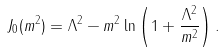Convert formula to latex. <formula><loc_0><loc_0><loc_500><loc_500>J _ { 0 } ( m ^ { 2 } ) = \Lambda ^ { 2 } - m ^ { 2 } \ln \left ( 1 + \frac { \Lambda ^ { 2 } } { m ^ { 2 } } \right ) .</formula> 